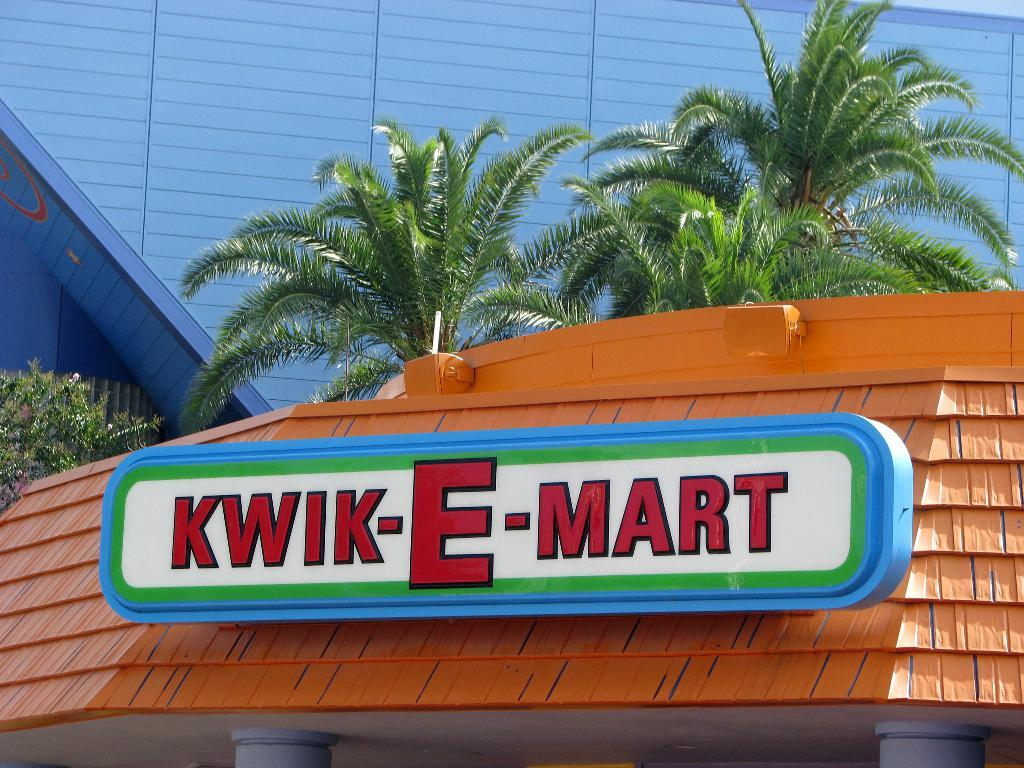What is the main object in the middle of the picture? There is a board in the middle of the picture. What can be seen in the background of the picture? There are trees and buildings in the background of the picture. What type of bean is growing on the board in the image? There is no bean present in the image; the board is the main object in the middle of the picture. 